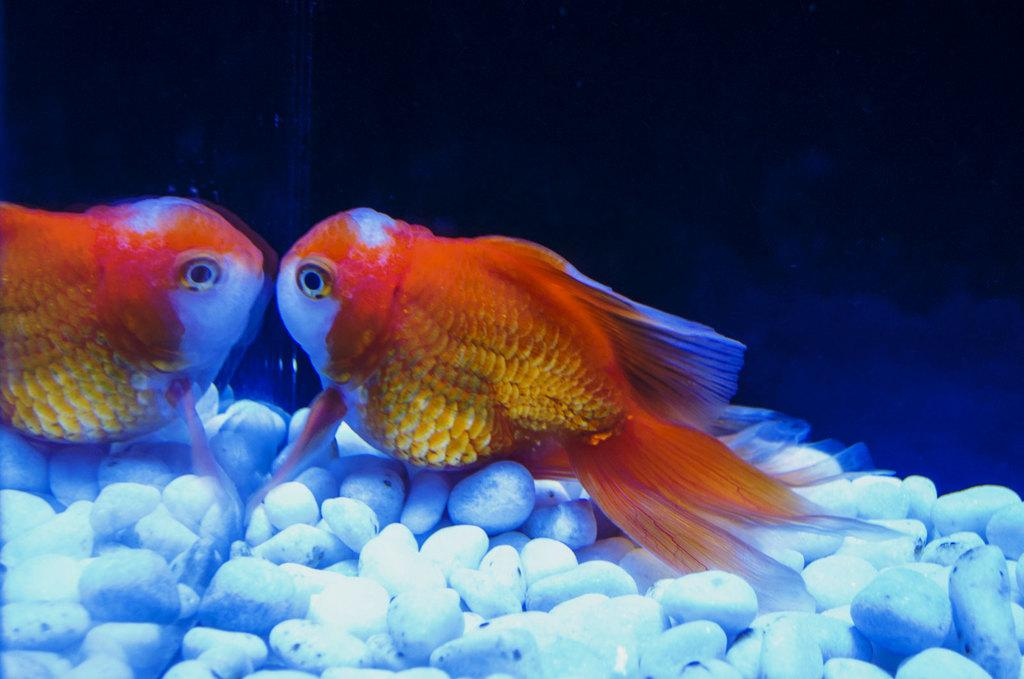What type of animals can be seen in the image? There are fish in the image. What other objects are present in the image besides the fish? There are stones in the image. Can you describe the background of the image? The background of the image is dark. What type of egg can be seen in the image? There is no egg present in the image. What is the fish having for lunch in the image? The image does not depict the fish eating or having lunch, so it cannot be determined from the image. 